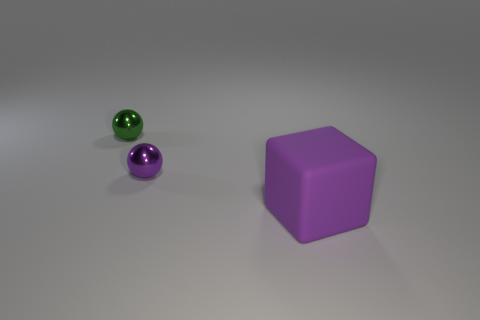What could be the significance of the color choice in this image? Color choices in images can affect mood and symbolism. Here, the use of purple might evoke feelings of luxury or creativity, given that it's often associated with those concepts. The contrasting green object could symbolize balance, as green is known for its soothing and refreshing qualities. 